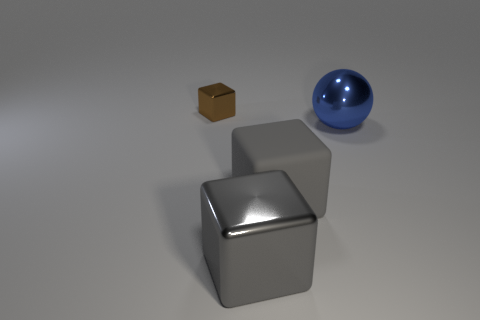Is the thing behind the blue object made of the same material as the large gray object that is left of the rubber block?
Provide a short and direct response. Yes. Is the number of gray shiny cubes to the right of the large metal sphere the same as the number of big blue things in front of the matte object?
Make the answer very short. Yes. What is the color of the rubber object that is the same size as the blue metal ball?
Keep it short and to the point. Gray. Are there any rubber things of the same color as the large matte cube?
Offer a very short reply. No. How many things are cubes that are behind the rubber object or tiny yellow metal cubes?
Offer a terse response. 1. How many other objects are the same size as the metallic sphere?
Ensure brevity in your answer.  2. What is the material of the large gray cube behind the metal cube right of the metallic cube that is behind the big shiny sphere?
Your answer should be very brief. Rubber. What number of spheres are either tiny yellow metallic things or large gray shiny things?
Keep it short and to the point. 0. Are there any other things that have the same shape as the blue thing?
Provide a succinct answer. No. Is the number of tiny brown things that are to the right of the big gray matte thing greater than the number of metallic cubes in front of the large gray shiny cube?
Keep it short and to the point. No. 